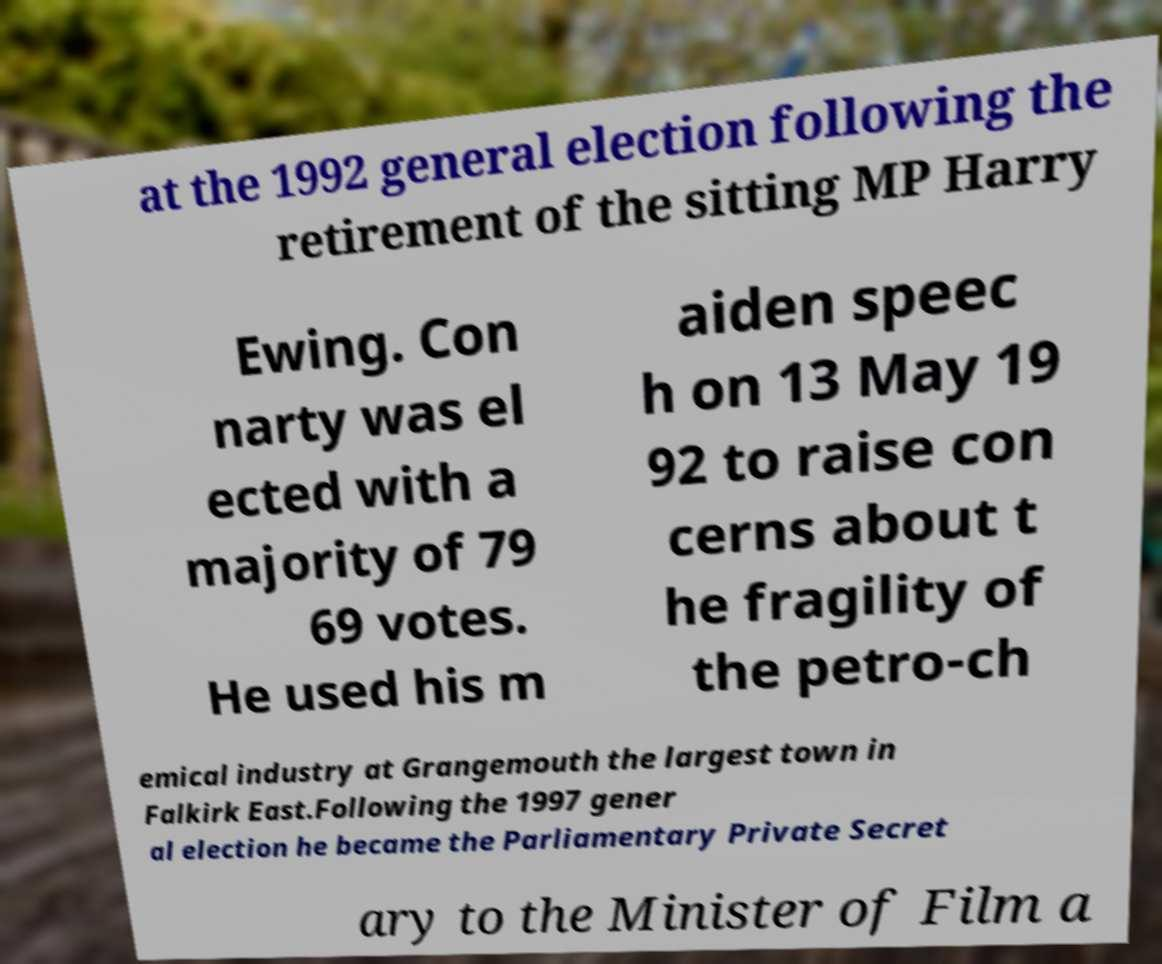Can you read and provide the text displayed in the image?This photo seems to have some interesting text. Can you extract and type it out for me? at the 1992 general election following the retirement of the sitting MP Harry Ewing. Con narty was el ected with a majority of 79 69 votes. He used his m aiden speec h on 13 May 19 92 to raise con cerns about t he fragility of the petro-ch emical industry at Grangemouth the largest town in Falkirk East.Following the 1997 gener al election he became the Parliamentary Private Secret ary to the Minister of Film a 